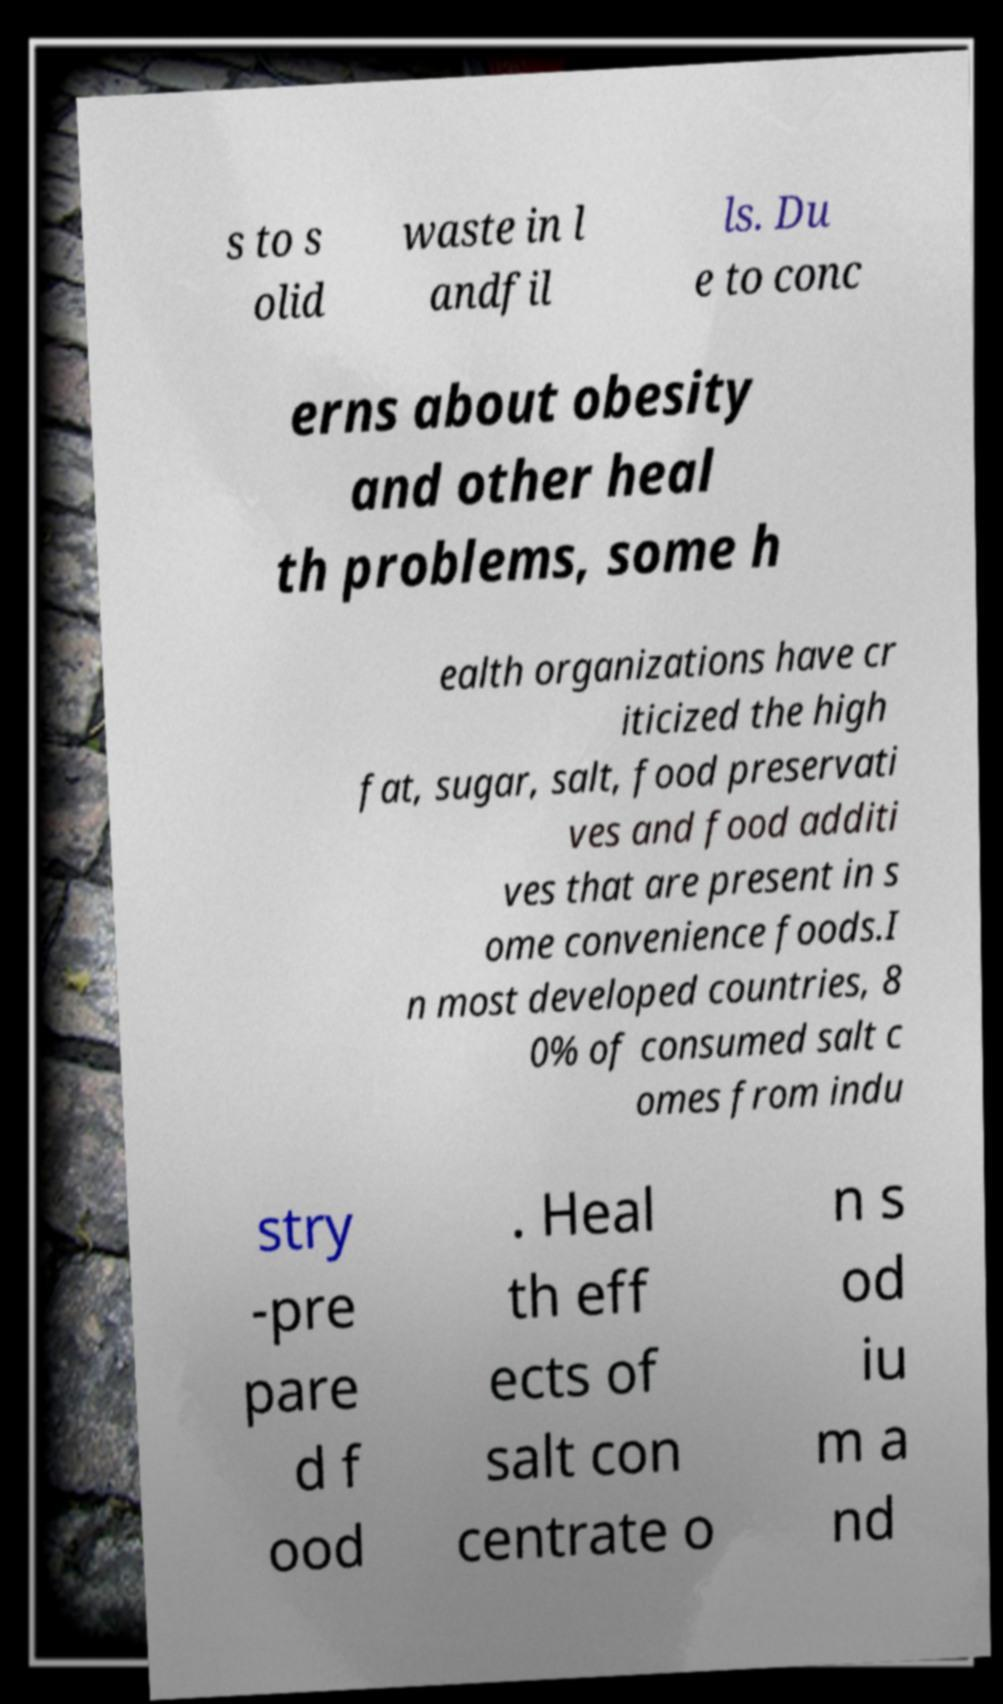There's text embedded in this image that I need extracted. Can you transcribe it verbatim? s to s olid waste in l andfil ls. Du e to conc erns about obesity and other heal th problems, some h ealth organizations have cr iticized the high fat, sugar, salt, food preservati ves and food additi ves that are present in s ome convenience foods.I n most developed countries, 8 0% of consumed salt c omes from indu stry -pre pare d f ood . Heal th eff ects of salt con centrate o n s od iu m a nd 